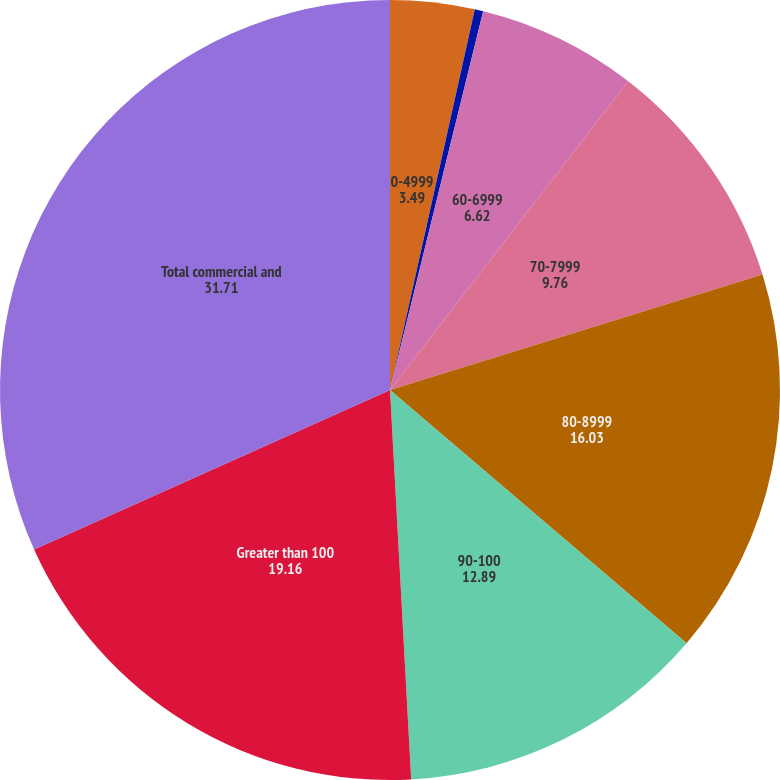<chart> <loc_0><loc_0><loc_500><loc_500><pie_chart><fcel>0-4999<fcel>50-5999<fcel>60-6999<fcel>70-7999<fcel>80-8999<fcel>90-100<fcel>Greater than 100<fcel>Total commercial and<nl><fcel>3.49%<fcel>0.35%<fcel>6.62%<fcel>9.76%<fcel>16.03%<fcel>12.89%<fcel>19.16%<fcel>31.71%<nl></chart> 